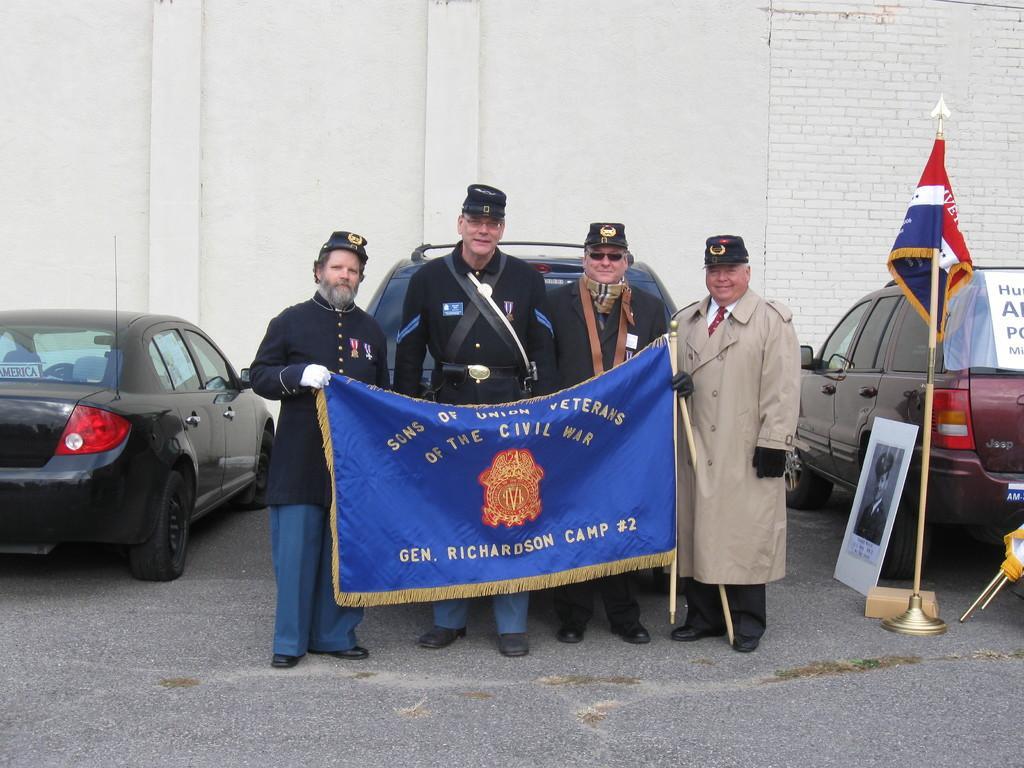Describe this image in one or two sentences. In this image there are a few people standing and holding a banner, behind them there are cars, placards, flags, behind the cars there is a wall. 